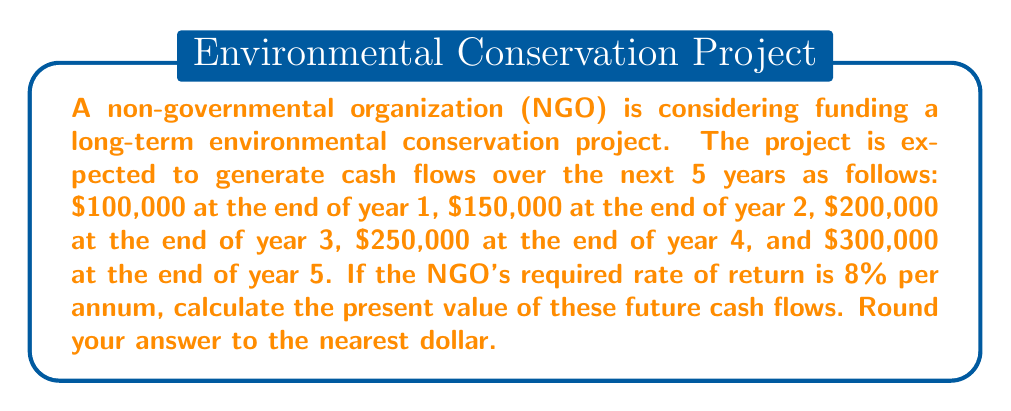Solve this math problem. To calculate the present value of future cash flows, we need to discount each cash flow back to the present using the given discount rate. The formula for the present value (PV) of a single future cash flow is:

$$ PV = \frac{FV}{(1 + r)^n} $$

Where:
- FV is the future value (cash flow)
- r is the discount rate (required rate of return)
- n is the number of periods (years)

For multiple cash flows, we sum the present values of each individual cash flow. Let's calculate the PV for each year:

Year 1: $$ PV_1 = \frac{100,000}{(1 + 0.08)^1} = \frac{100,000}{1.08} = 92,592.59 $$

Year 2: $$ PV_2 = \frac{150,000}{(1 + 0.08)^2} = \frac{150,000}{1.1664} = 128,601.68 $$

Year 3: $$ PV_3 = \frac{200,000}{(1 + 0.08)^3} = \frac{200,000}{1.2597} = 158,768.75 $$

Year 4: $$ PV_4 = \frac{250,000}{(1 + 0.08)^4} = \frac{250,000}{1.3605} = 183,756.71 $$

Year 5: $$ PV_5 = \frac{300,000}{(1 + 0.08)^5} = \frac{300,000}{1.4693} = 204,178.86 $$

Now, we sum all these present values:

$$ PV_{total} = 92,592.59 + 128,601.68 + 158,768.75 + 183,756.71 + 204,178.86 = 767,898.59 $$

Rounding to the nearest dollar, we get $767,899.
Answer: $767,899 